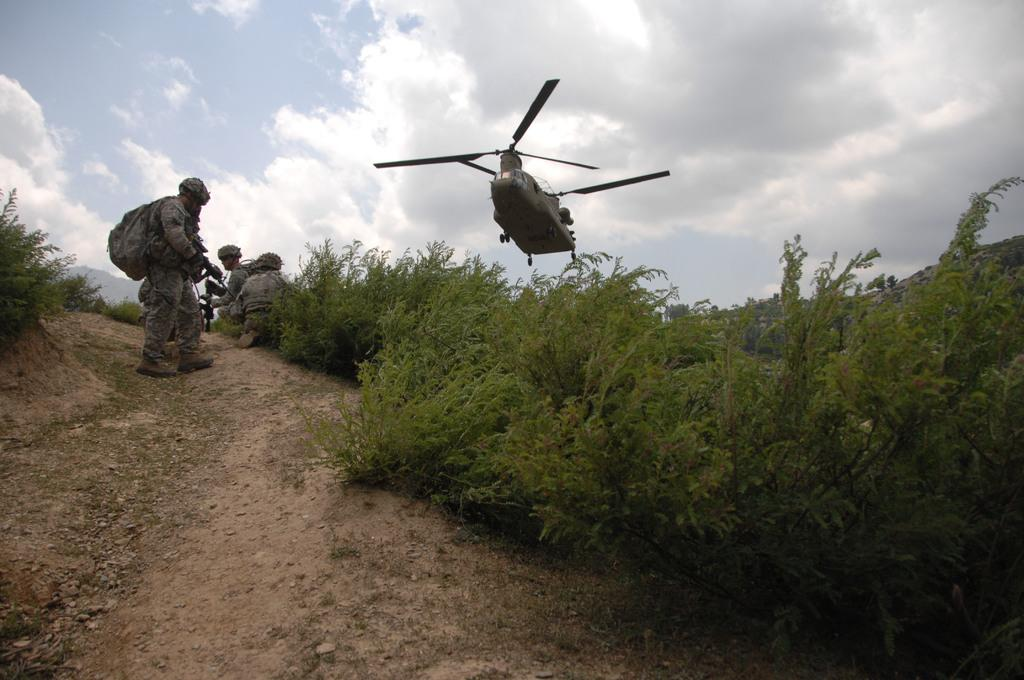What type of people are present in the image? There are army people in the image. What mode of transportation can be seen in the image? There is a plane in the image. What type of natural vegetation is visible in the image? There are trees visible in the image. What type of patch can be seen on the army people's uniforms in the image? There is no specific patch mentioned in the provided facts, and therefore it cannot be determined from the image. What type of fruit is being used as a prop by the army people in the image? There is no fruit, specifically quince, present in the image. 